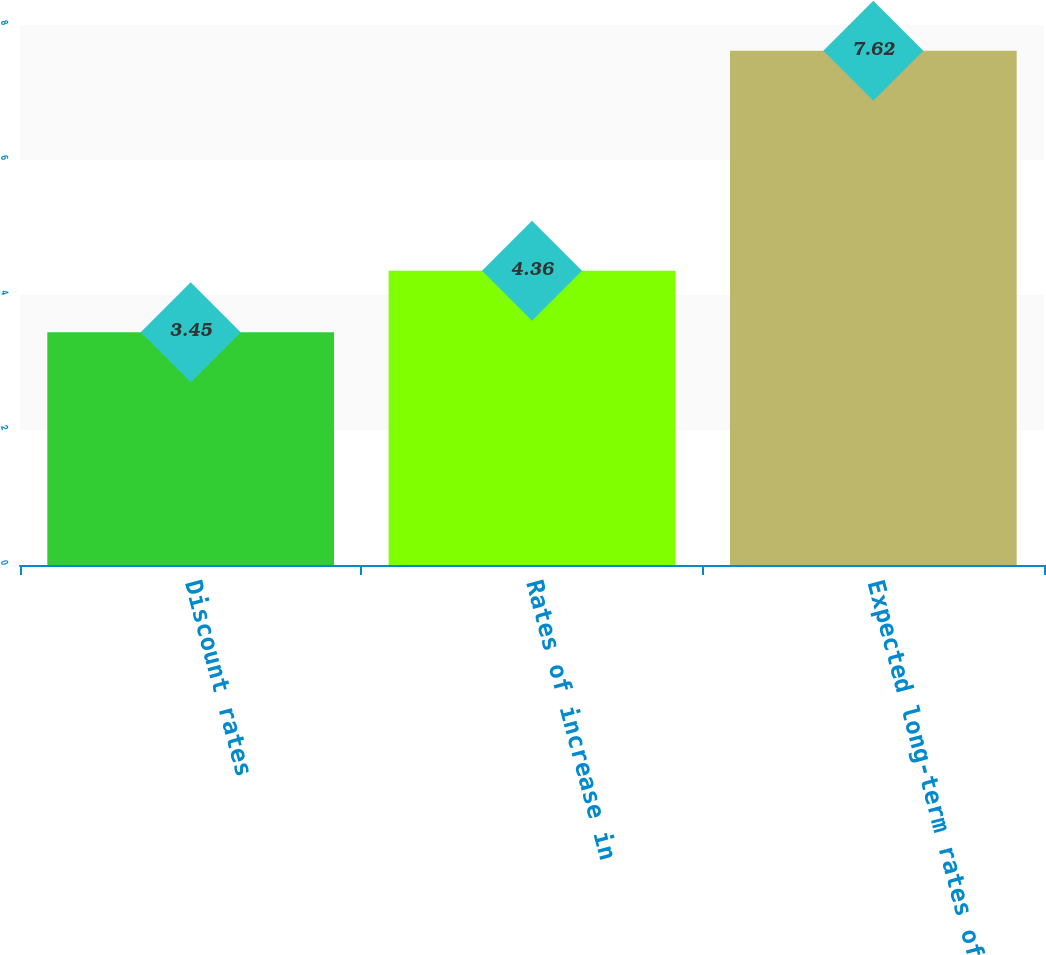Convert chart. <chart><loc_0><loc_0><loc_500><loc_500><bar_chart><fcel>Discount rates<fcel>Rates of increase in<fcel>Expected long-term rates of<nl><fcel>3.45<fcel>4.36<fcel>7.62<nl></chart> 